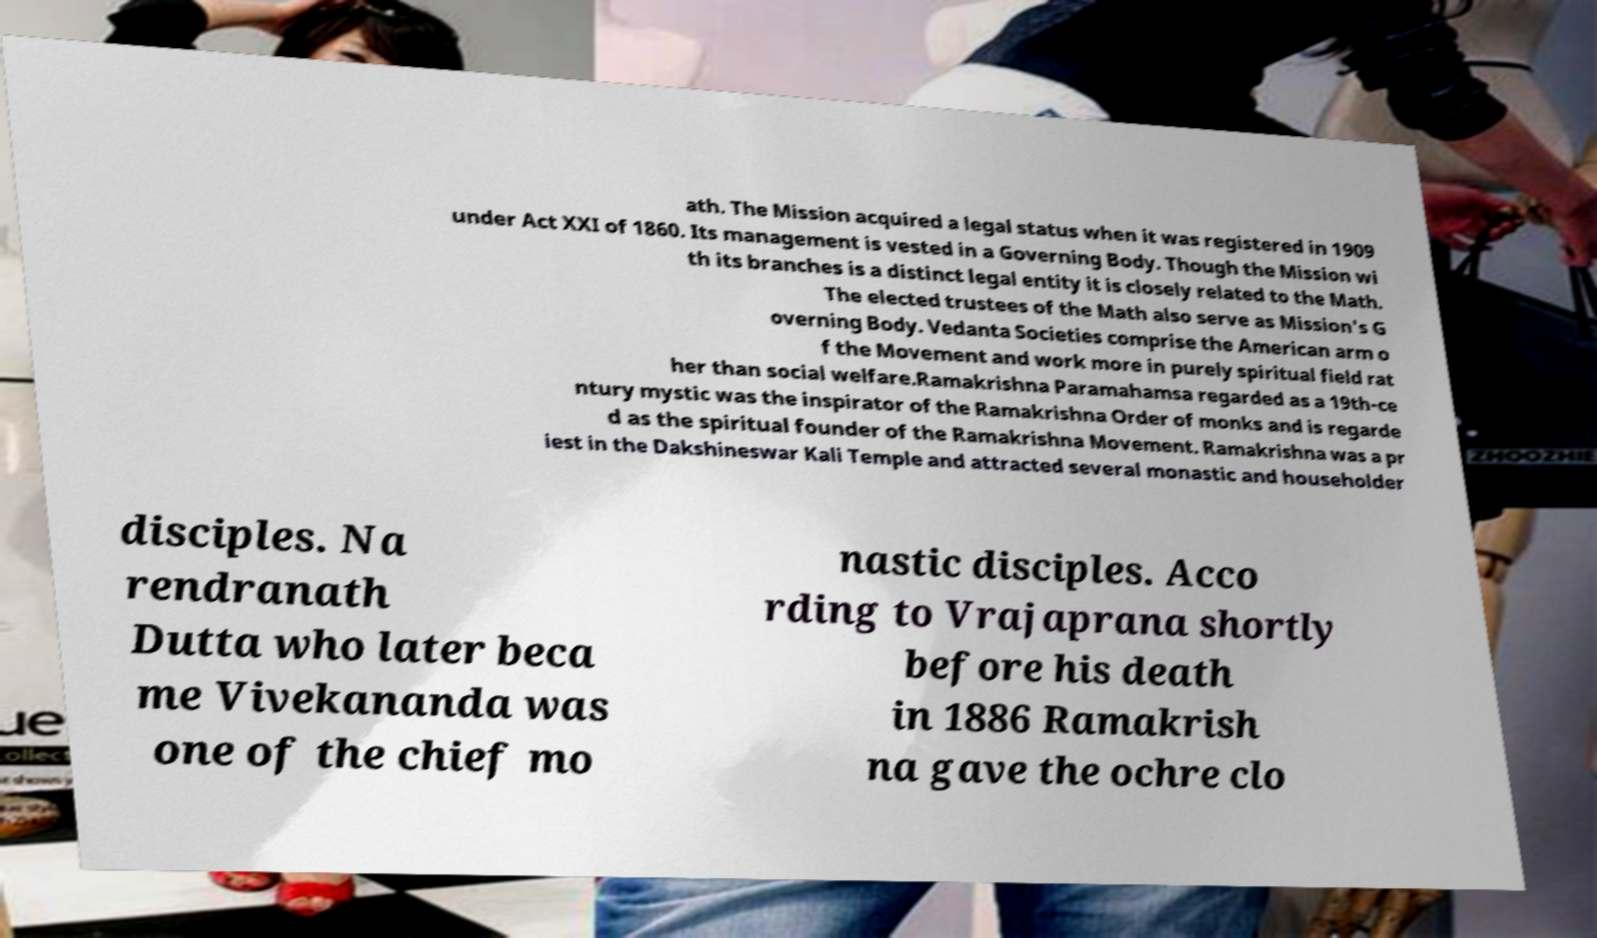What messages or text are displayed in this image? I need them in a readable, typed format. ath. The Mission acquired a legal status when it was registered in 1909 under Act XXI of 1860. Its management is vested in a Governing Body. Though the Mission wi th its branches is a distinct legal entity it is closely related to the Math. The elected trustees of the Math also serve as Mission's G overning Body. Vedanta Societies comprise the American arm o f the Movement and work more in purely spiritual field rat her than social welfare.Ramakrishna Paramahamsa regarded as a 19th-ce ntury mystic was the inspirator of the Ramakrishna Order of monks and is regarde d as the spiritual founder of the Ramakrishna Movement. Ramakrishna was a pr iest in the Dakshineswar Kali Temple and attracted several monastic and householder disciples. Na rendranath Dutta who later beca me Vivekananda was one of the chief mo nastic disciples. Acco rding to Vrajaprana shortly before his death in 1886 Ramakrish na gave the ochre clo 